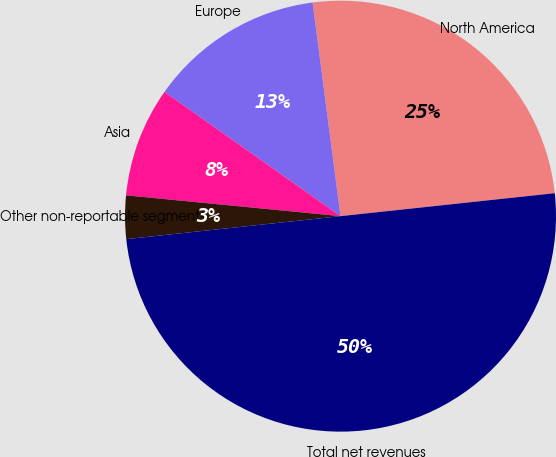Convert chart to OTSL. <chart><loc_0><loc_0><loc_500><loc_500><pie_chart><fcel>North America<fcel>Europe<fcel>Asia<fcel>Other non-reportable segments<fcel>Total net revenues<nl><fcel>25.37%<fcel>13.15%<fcel>8.24%<fcel>3.24%<fcel>50.0%<nl></chart> 